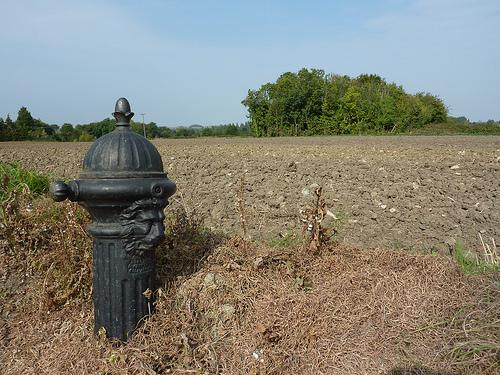Question: where is hydrant?
Choices:
A. Next to an office building.
B. In field.
C. Outside a school.
D. In a parking lot.
Answer with the letter. Answer: B Question: what color is the hydrant?
Choices:
A. Yellow.
B. Red.
C. Black.
D. Orange.
Answer with the letter. Answer: C Question: what animal is on the hydrant?
Choices:
A. Seal.
B. Tiger.
C. Wolf.
D. Lion.
Answer with the letter. Answer: D Question: what is all over the ground?
Choices:
A. Dirt.
B. Grass.
C. Flowers.
D. Rocks.
Answer with the letter. Answer: A Question: how many hydrants?
Choices:
A. One.
B. Two.
C. None.
D. Three.
Answer with the letter. Answer: A Question: when was this taken?
Choices:
A. At night.
B. At dawn.
C. At dusk.
D. During the day.
Answer with the letter. Answer: D 